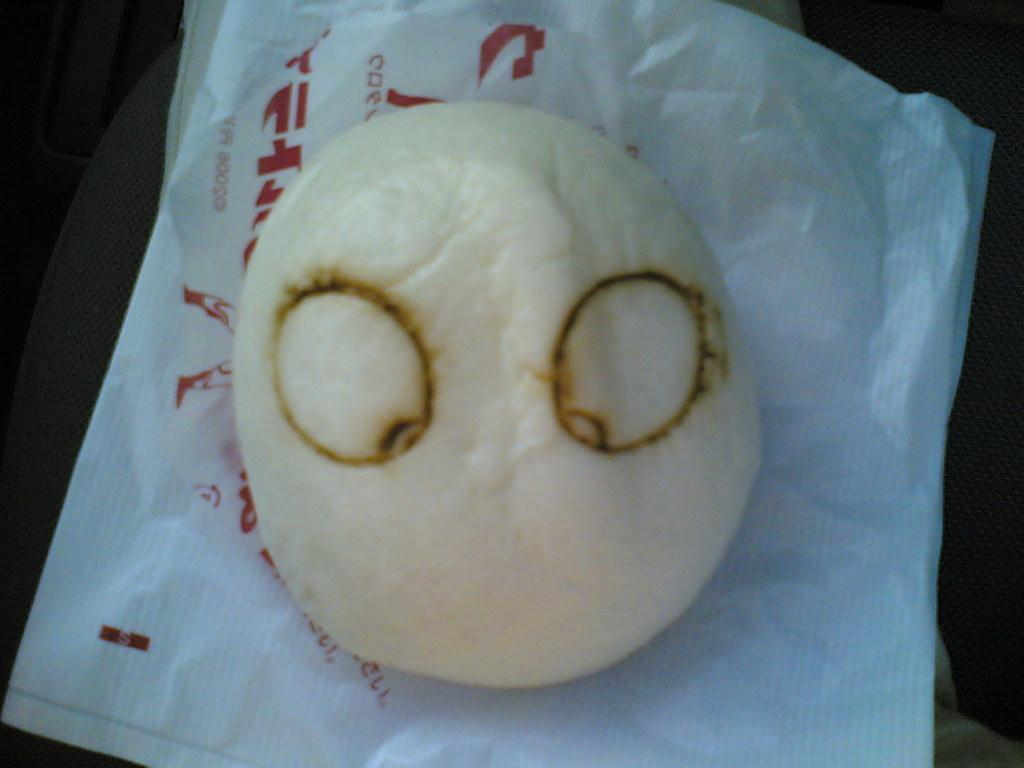What is the main subject of the image? There is an object on paper in the image. How many frogs can be seen jumping around the object on paper in the image? There are no frogs present in the image; it only features an object on paper. Is the object on paper in the image currently burning? There is no indication in the image that the object on paper is burning or has been burned. 